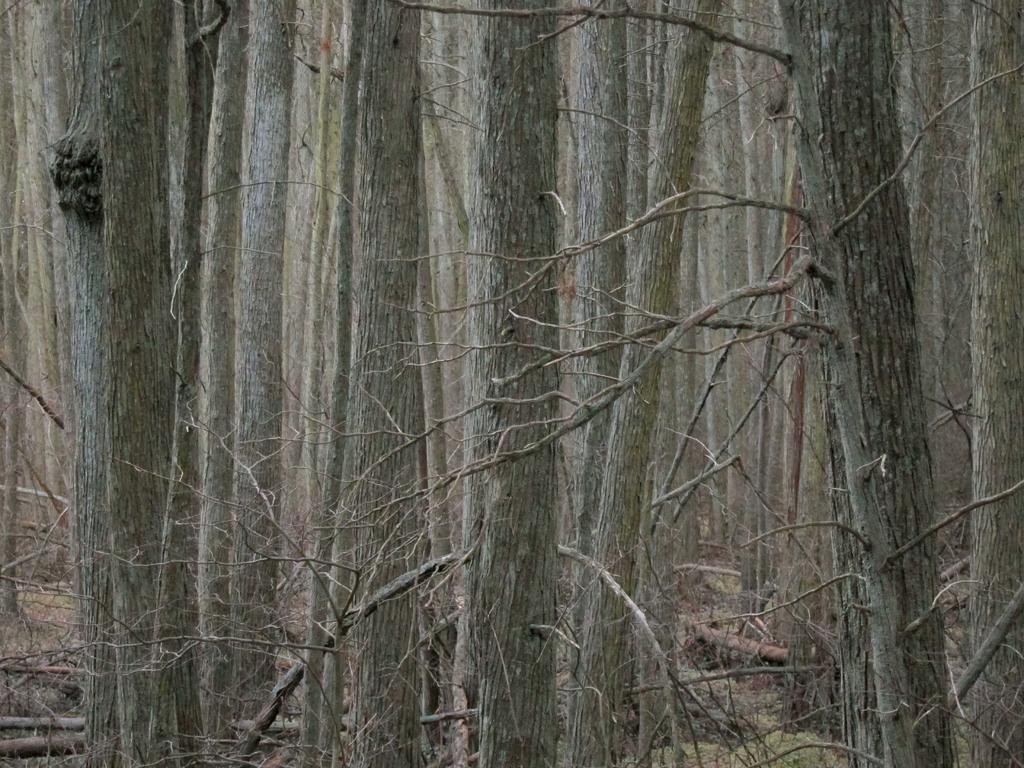What is the primary feature of the image? The primary feature of the image is the presence of many trees. Can you describe the landscape in the image? The landscape in the image is dominated by trees. What type of environment might this image depict? The image might depict a forest or wooded area. How do the trees say good-bye to each other in the image? Trees do not have the ability to say good-bye, as they are inanimate objects. 